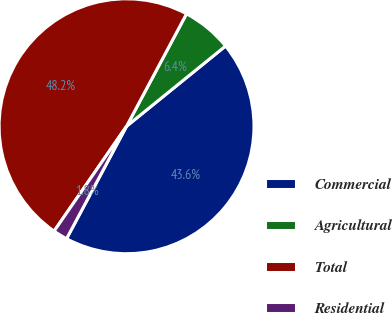Convert chart. <chart><loc_0><loc_0><loc_500><loc_500><pie_chart><fcel>Commercial<fcel>Agricultural<fcel>Total<fcel>Residential<nl><fcel>43.64%<fcel>6.36%<fcel>48.18%<fcel>1.82%<nl></chart> 